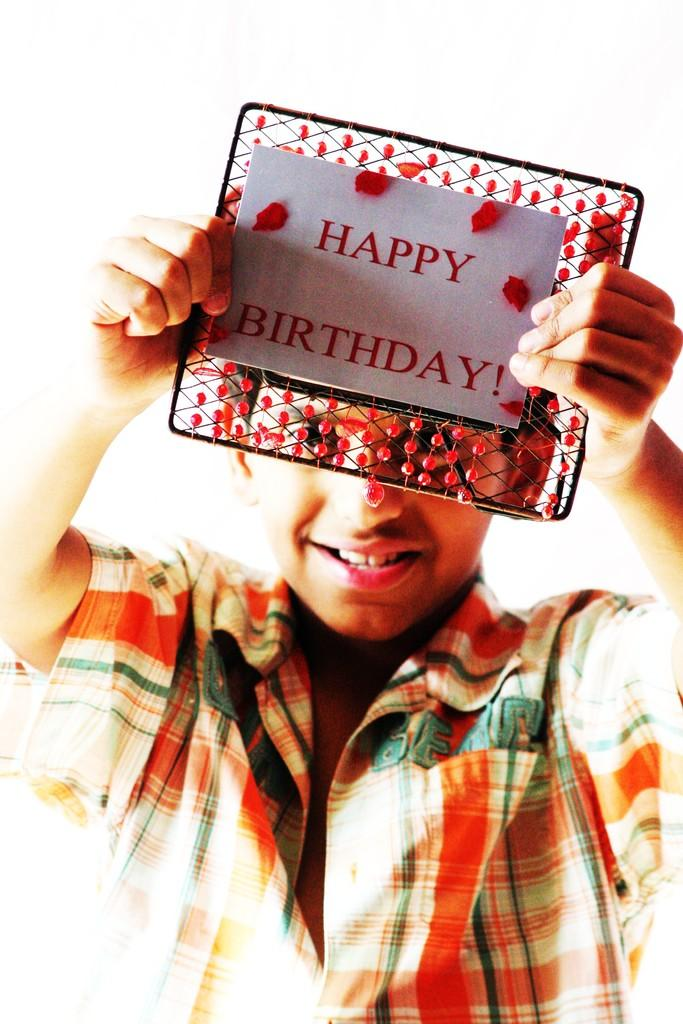What is the person in the image holding? The person is holding a card. What is written on the card? The card has "Happy Birthday" written on it. Can you see any letters or twigs in the image? There are no letters or twigs present in the image. Is there a fire visible in the image? There is no fire visible in the image. 